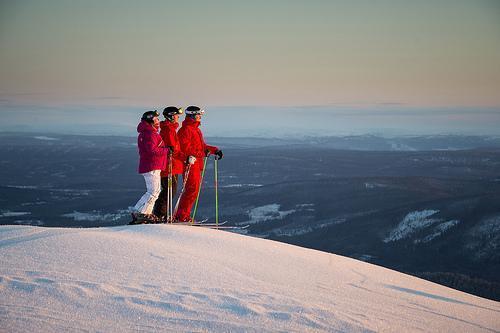How many people are there?
Give a very brief answer. 3. 